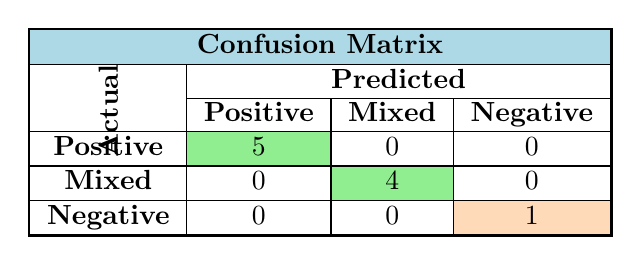What is the total number of reviews with positive sentiment? In the table, under the "Positive" row and "Actual" column, there are 5 positive reviews.
Answer: 5 How many reviews were classified as mixed sentiment? In the table, under the "Mixed" row and "Actual" column, there are 4 reviews classified as mixed sentiment.
Answer: 4 What is the count of negative sentiment predictions in the confusion matrix? In the table, under the "Negative" row and "Actual" column, there is 1 review classified as negative sentiment.
Answer: 1 Are there any reviews incorrectly predicted as positive? Looking at the "Positive" row, there are no counts in the "Mixed" or "Negative" columns, meaning all positive reviews were correctly classified.
Answer: No How many reviews were predicted as negative but were actually mixed? The table shows 0 reviews in the "Negative" column that belong to the "Mixed" row, indicating that no mixed reviews were incorrectly classified as negative.
Answer: 0 What is the total number of reviews classified as mixed or negative? The total of mixed reviews is 4 and negative reviews is 1, summing these gives 4 + 1 = 5.
Answer: 5 What percentage of positive reviews were correctly classified as positive? There are 5 positive reviews, all classified correctly as positive, resulting in a percentage of (5/5) * 100 = 100%.
Answer: 100% If we sum the positive and mixed predictions, what is the total? The positive predictions are 5 and mixed predictions are 4, so the sum is 5 + 4 = 9.
Answer: 9 How many total reviews were processed in the confusion matrix? By adding all values from the actual sentiments (5 positive + 4 mixed + 1 negative), we find the total reviews are 5 + 4 + 1 = 10.
Answer: 10 